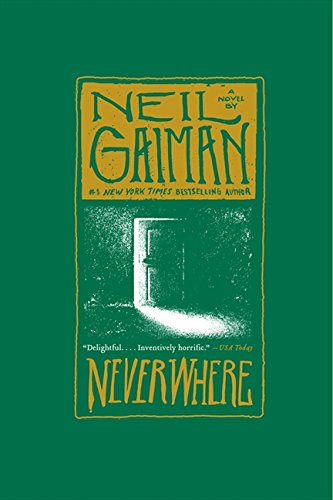Who wrote this book? Neil Gaiman is the renowned author of this engaging novel, known for his distinctive style in modern fantasy and storytelling. 